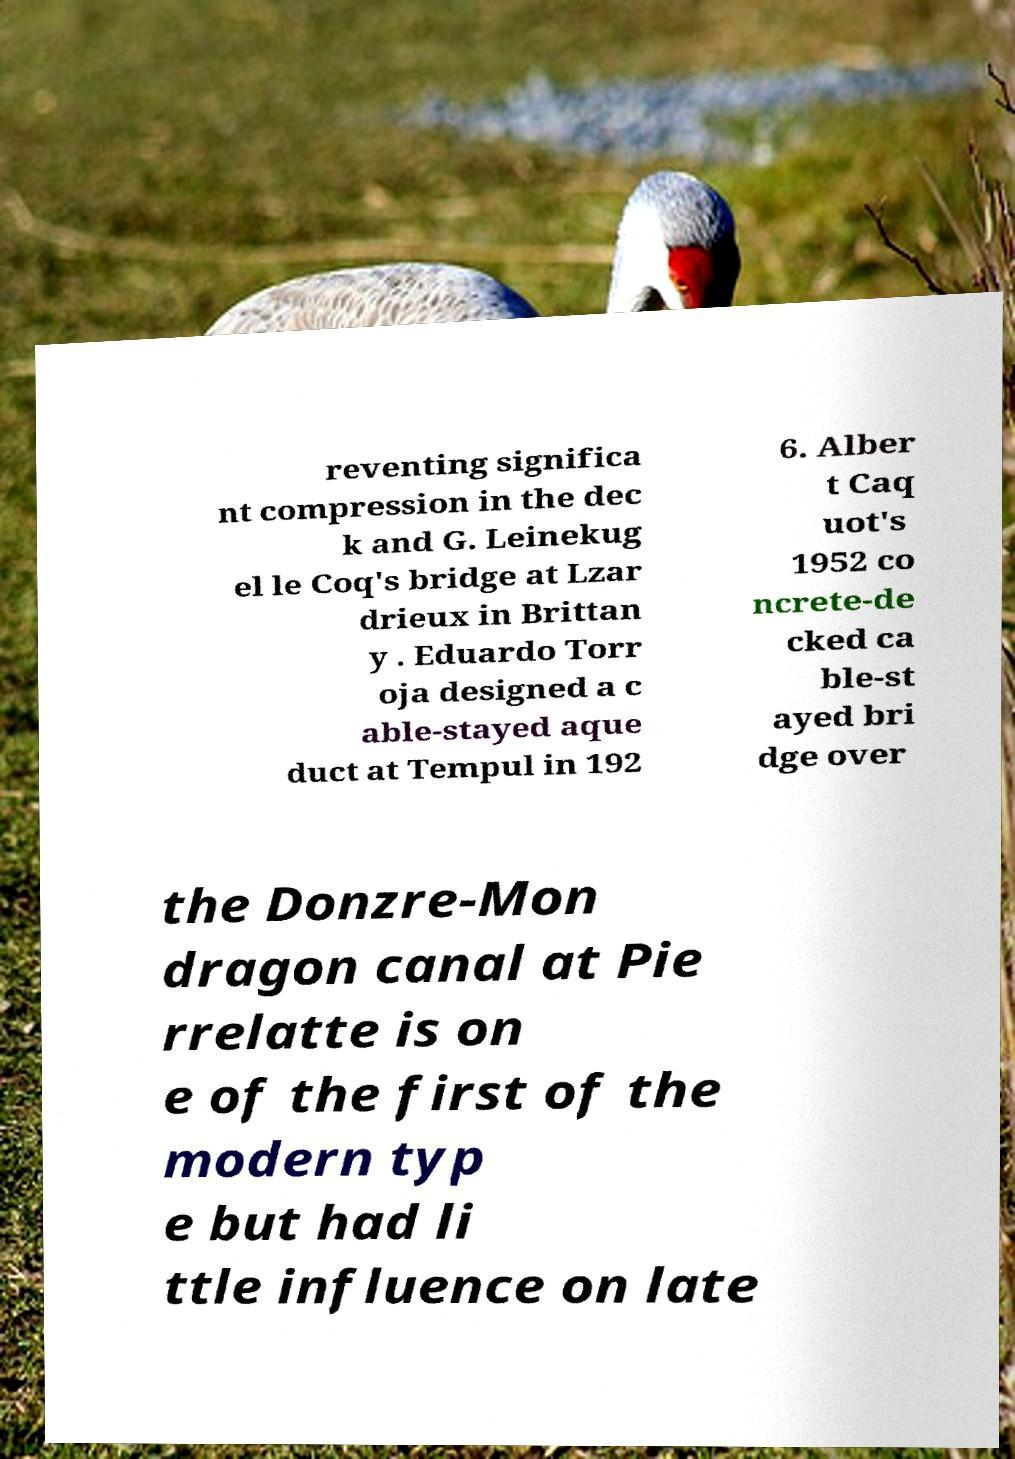Could you assist in decoding the text presented in this image and type it out clearly? reventing significa nt compression in the dec k and G. Leinekug el le Coq's bridge at Lzar drieux in Brittan y . Eduardo Torr oja designed a c able-stayed aque duct at Tempul in 192 6. Alber t Caq uot's 1952 co ncrete-de cked ca ble-st ayed bri dge over the Donzre-Mon dragon canal at Pie rrelatte is on e of the first of the modern typ e but had li ttle influence on late 